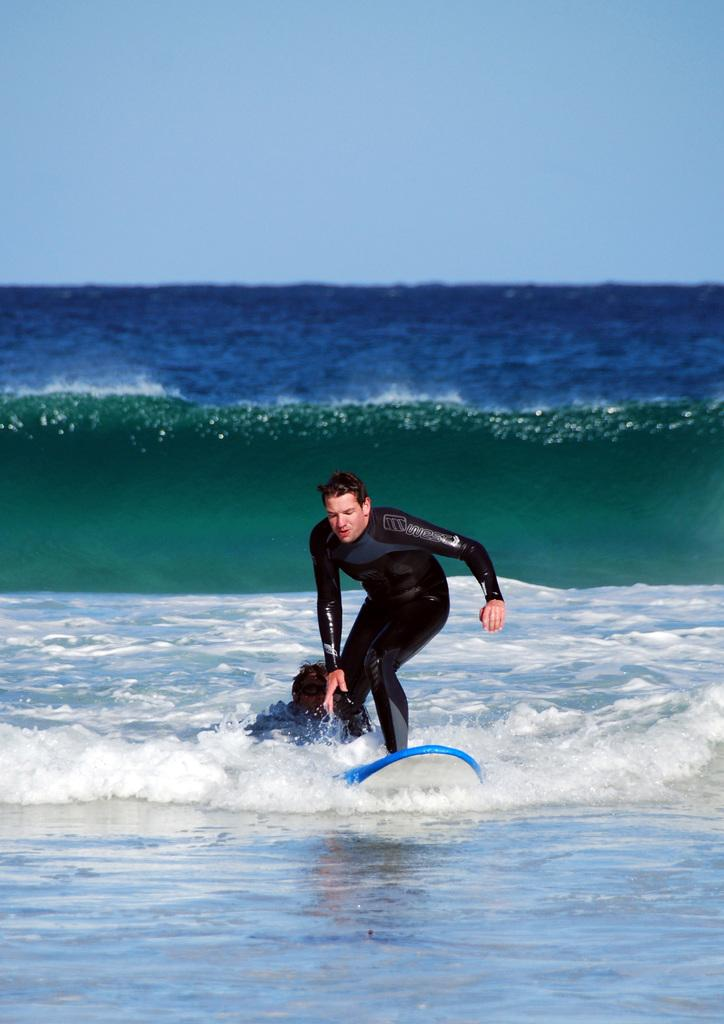What is the main subject of the image? There is a man in the image. What is the man wearing? The man is wearing a black T-shirt. What activity is the man engaged in? The man is surfing on the water. What can be seen in the background of the image? The background of the image includes water. Can you describe the type of water in the image? The water might be in the sea or ocean. What type of string can be seen tied to the man's surfboard in the image? There is no string tied to the man's surfboard in the image. Can you tell me how many copper pipes are visible in the image? There are no copper pipes present in the image. 